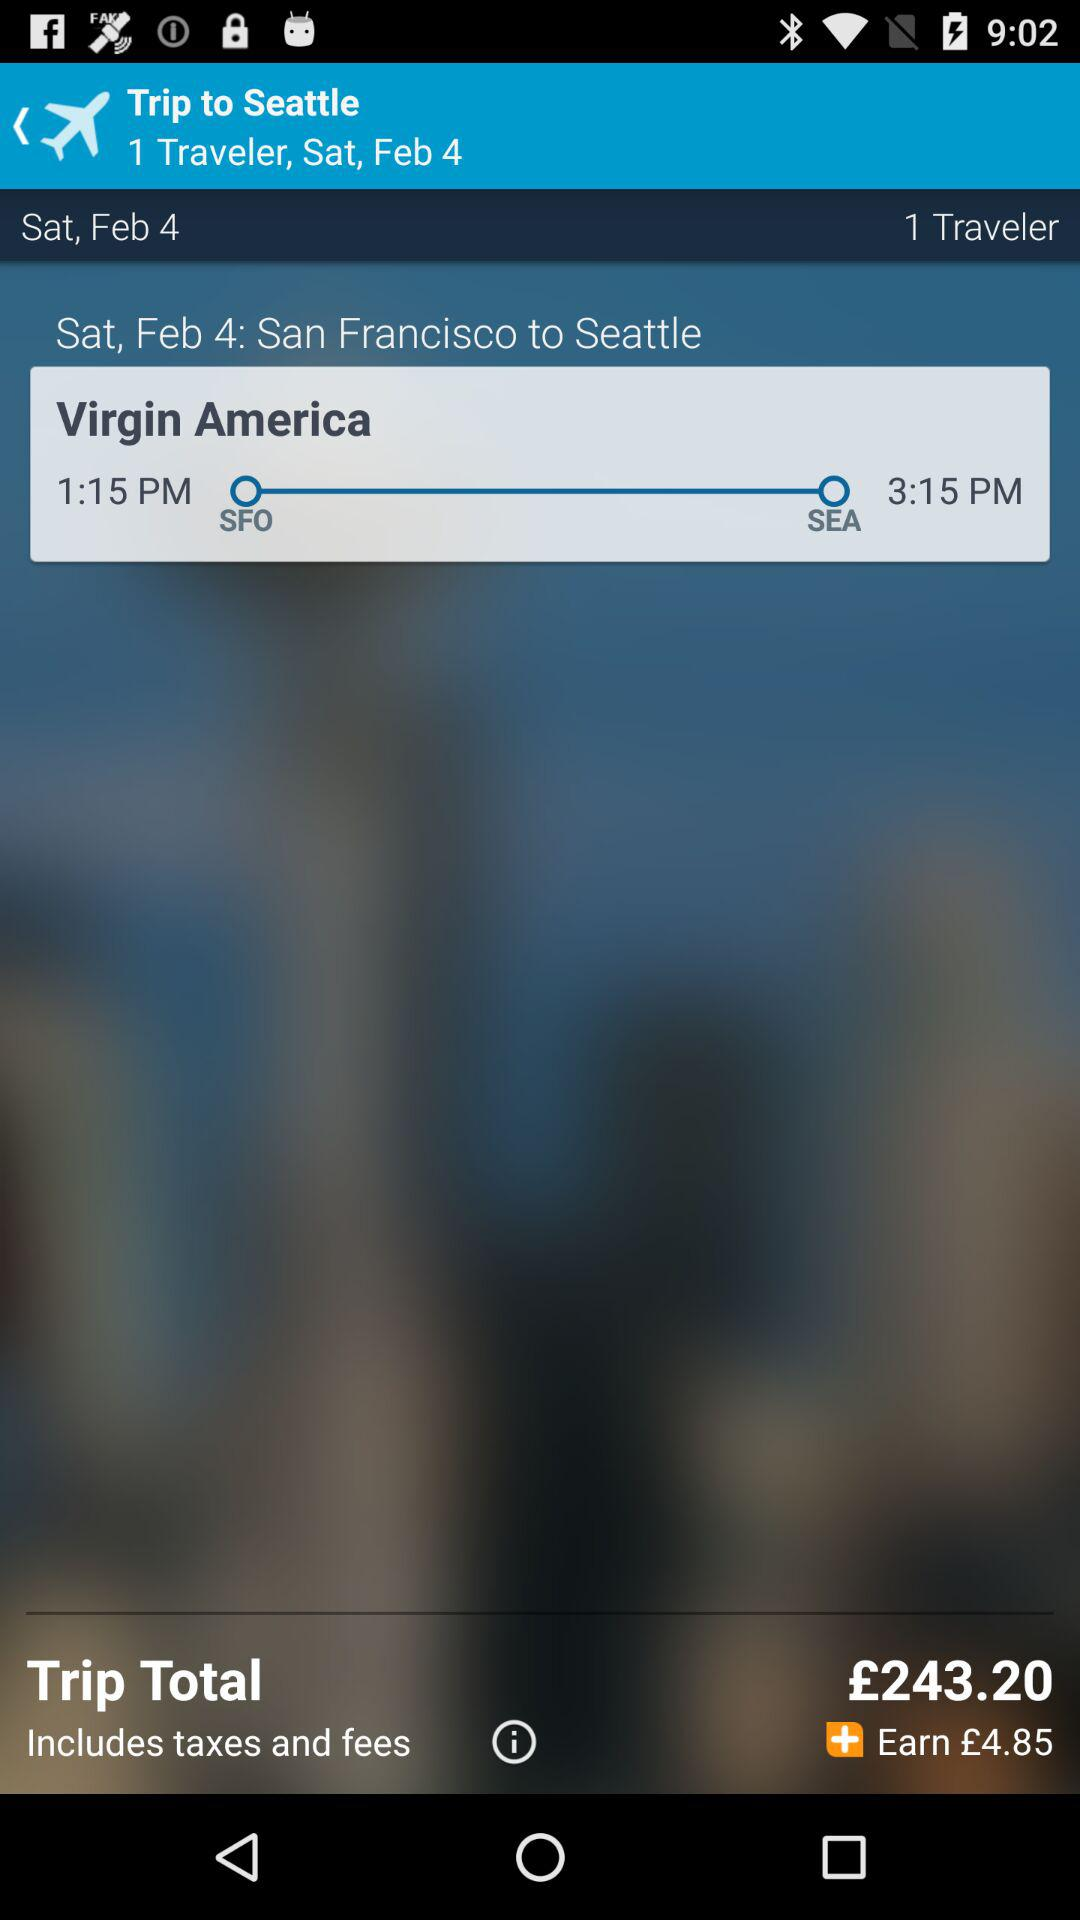How much money will I earn if I book this flight?
Answer the question using a single word or phrase. £4.85 